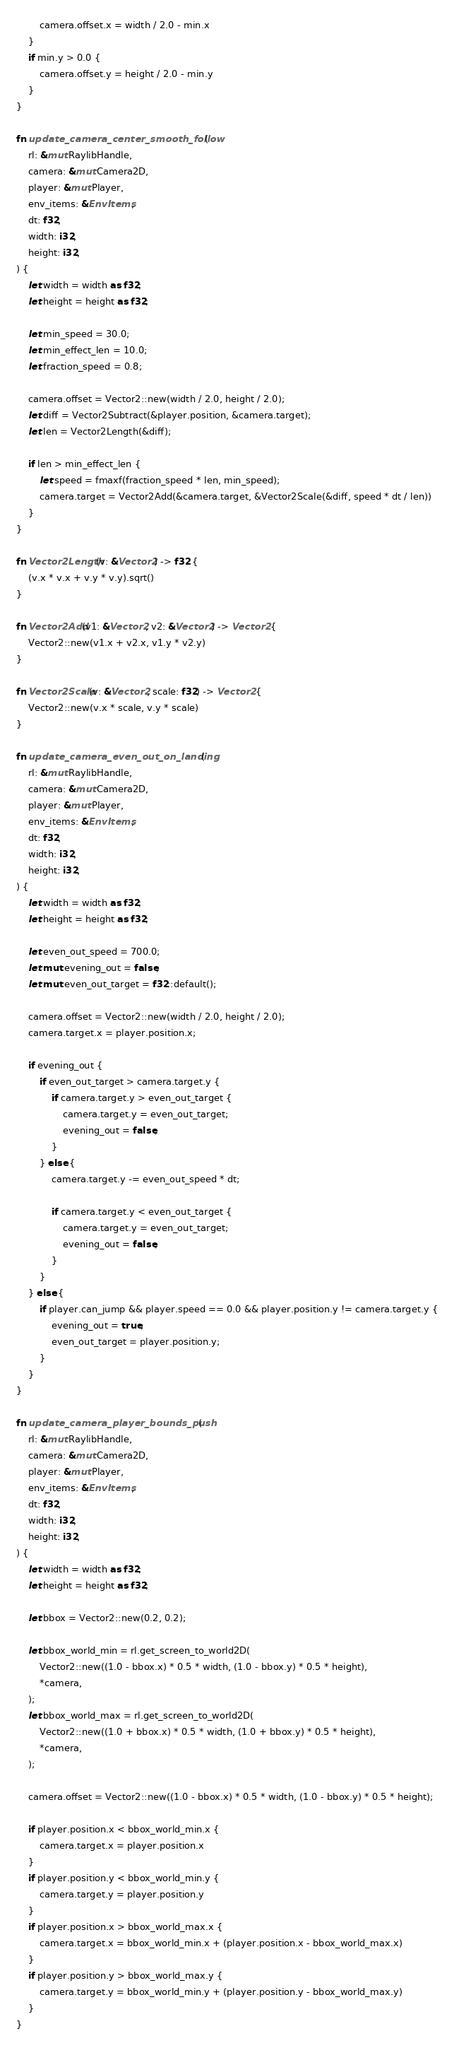<code> <loc_0><loc_0><loc_500><loc_500><_Rust_>        camera.offset.x = width / 2.0 - min.x
    }
    if min.y > 0.0 {
        camera.offset.y = height / 2.0 - min.y
    }
}

fn update_camera_center_smooth_follow(
    rl: &mut RaylibHandle,
    camera: &mut Camera2D,
    player: &mut Player,
    env_items: &EnvItems,
    dt: f32,
    width: i32,
    height: i32,
) {
    let width = width as f32;
    let height = height as f32;

    let min_speed = 30.0;
    let min_effect_len = 10.0;
    let fraction_speed = 0.8;

    camera.offset = Vector2::new(width / 2.0, height / 2.0);
    let diff = Vector2Subtract(&player.position, &camera.target);
    let len = Vector2Length(&diff);

    if len > min_effect_len {
        let speed = fmaxf(fraction_speed * len, min_speed);
        camera.target = Vector2Add(&camera.target, &Vector2Scale(&diff, speed * dt / len))
    }
}

fn Vector2Length(v: &Vector2) -> f32 {
    (v.x * v.x + v.y * v.y).sqrt()
}

fn Vector2Add(v1: &Vector2, v2: &Vector2) -> Vector2 {
    Vector2::new(v1.x + v2.x, v1.y * v2.y)
}

fn Vector2Scale(v: &Vector2, scale: f32) -> Vector2 {
    Vector2::new(v.x * scale, v.y * scale)
}

fn update_camera_even_out_on_landing(
    rl: &mut RaylibHandle,
    camera: &mut Camera2D,
    player: &mut Player,
    env_items: &EnvItems,
    dt: f32,
    width: i32,
    height: i32,
) {
    let width = width as f32;
    let height = height as f32;

    let even_out_speed = 700.0;
    let mut evening_out = false;
    let mut even_out_target = f32::default();

    camera.offset = Vector2::new(width / 2.0, height / 2.0);
    camera.target.x = player.position.x;

    if evening_out {
        if even_out_target > camera.target.y {
            if camera.target.y > even_out_target {
                camera.target.y = even_out_target;
                evening_out = false;
            }
        } else {
            camera.target.y -= even_out_speed * dt;

            if camera.target.y < even_out_target {
                camera.target.y = even_out_target;
                evening_out = false;
            }
        }
    } else {
        if player.can_jump && player.speed == 0.0 && player.position.y != camera.target.y {
            evening_out = true;
            even_out_target = player.position.y;
        }
    }
}

fn update_camera_player_bounds_push(
    rl: &mut RaylibHandle,
    camera: &mut Camera2D,
    player: &mut Player,
    env_items: &EnvItems,
    dt: f32,
    width: i32,
    height: i32,
) {
    let width = width as f32;
    let height = height as f32;

    let bbox = Vector2::new(0.2, 0.2);

    let bbox_world_min = rl.get_screen_to_world2D(
        Vector2::new((1.0 - bbox.x) * 0.5 * width, (1.0 - bbox.y) * 0.5 * height),
        *camera,
    );
    let bbox_world_max = rl.get_screen_to_world2D(
        Vector2::new((1.0 + bbox.x) * 0.5 * width, (1.0 + bbox.y) * 0.5 * height),
        *camera,
    );

    camera.offset = Vector2::new((1.0 - bbox.x) * 0.5 * width, (1.0 - bbox.y) * 0.5 * height);

    if player.position.x < bbox_world_min.x {
        camera.target.x = player.position.x
    }
    if player.position.y < bbox_world_min.y {
        camera.target.y = player.position.y
    }
    if player.position.x > bbox_world_max.x {
        camera.target.x = bbox_world_min.x + (player.position.x - bbox_world_max.x)
    }
    if player.position.y > bbox_world_max.y {
        camera.target.y = bbox_world_min.y + (player.position.y - bbox_world_max.y)
    }
}
</code> 